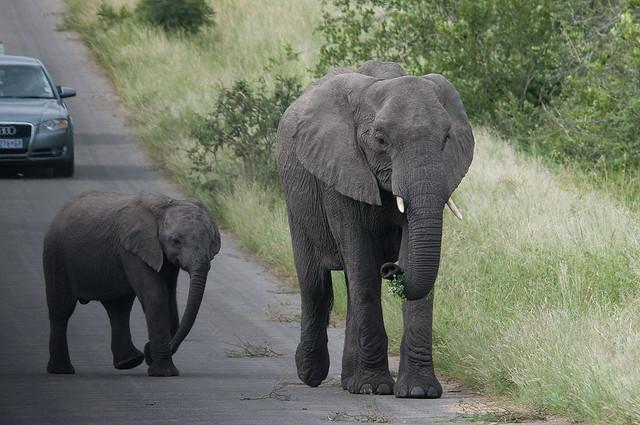What make of car is behind the elephants?

Choices:
A) mercedes benz
B) audi
C) chevrolet
D) ford audi 